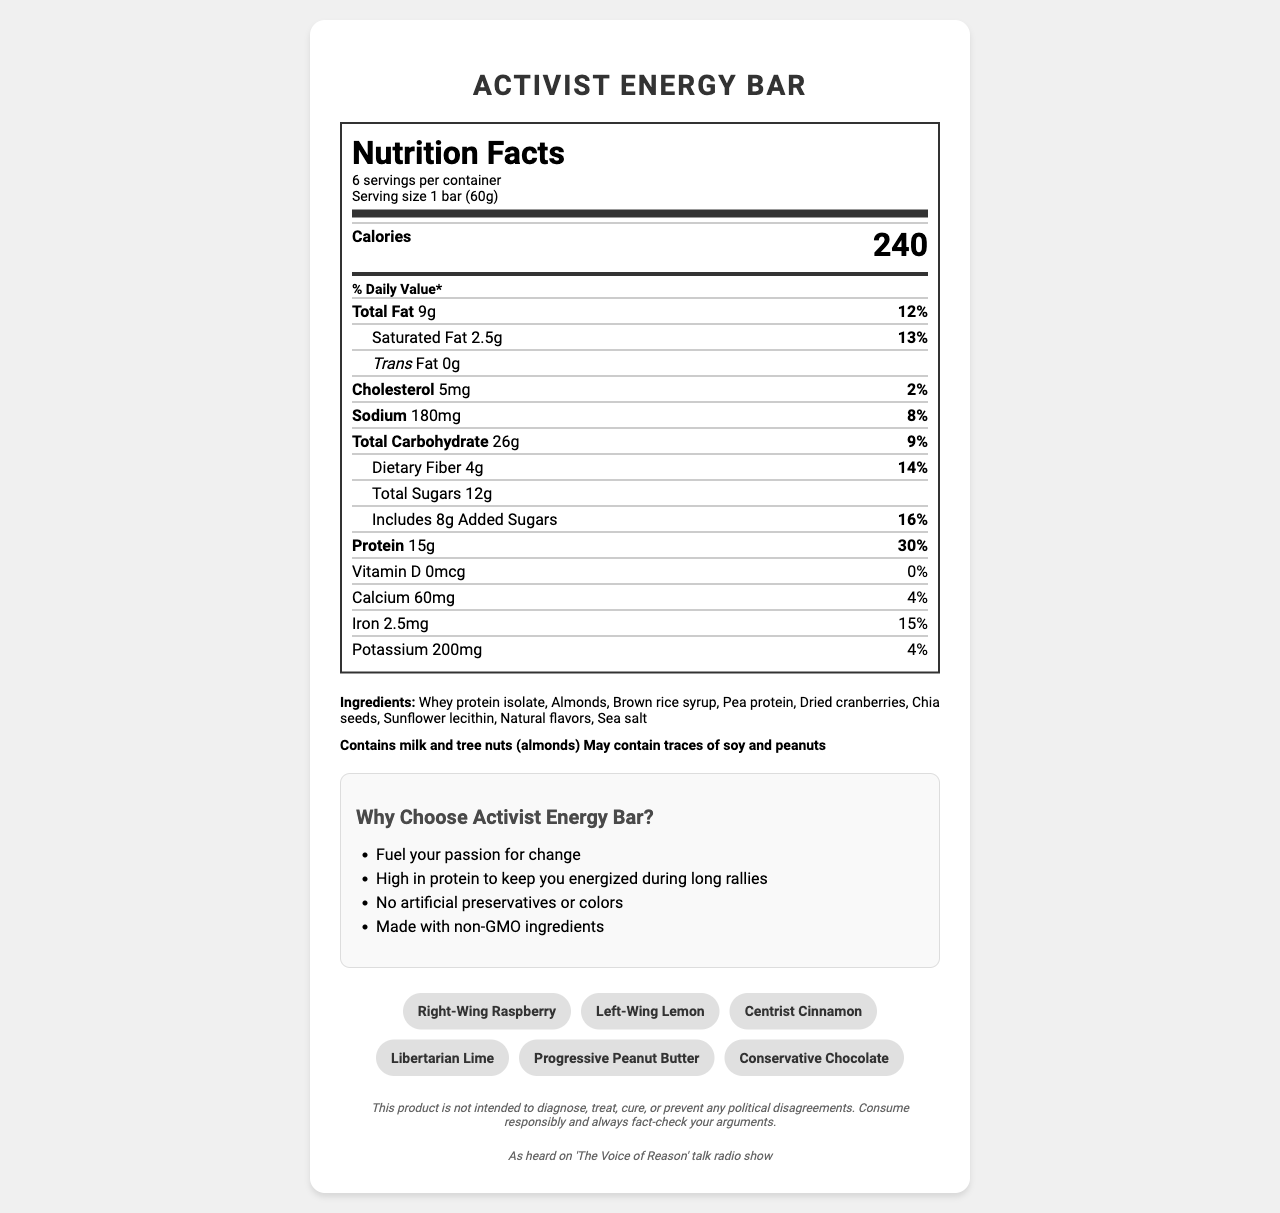what is the serving size? The serving size is listed as "1 bar (60g)" according to the document.
Answer: 1 bar (60g) how many servings are in one container? The document states that there are 6 servings per container.
Answer: 6 how many grams of protein are in one serving? The protein content per serving is stated as "15g".
Answer: 15g what percentage of the daily value of protein does one serving provide? The document indicates that one serving provides 30% of the daily value for protein.
Answer: 30% which ingredients are allergens? The allergens section lists milk and tree nuts (almonds) as allergens.
Answer: Milk and tree nuts (almonds) what is the main ingredient in the snack bar? A. Almonds B. Whey protein isolate C. Chia seeds D. Brown rice syrup The main ingredient is Whey protein isolate as it is listed first in the ingredients list.
Answer: B how many calories are there per serving? A. 240 B. 200 C. 180 D. 150 The document states there are 240 calories per serving.
Answer: A is the product marketed as non-GMO? The marketing claims include "Made with non-GMO ingredients".
Answer: Yes does the product contain artificial preservatives? One of the marketing claims is "No artificial preservatives or colors," indicating the product doesn't contain artificial preservatives.
Answer: No how much dietary fiber is in one serving? The dietary fiber content per serving is listed as "4g".
Answer: 4g what are some of the politically charged names of the flavors? These names are mentioned under the section "politically charged names".
Answer: Right-Wing Raspberry, Left-Wing Lemon, Centrist Cinnamon, Libertarian Lime, Progressive Peanut Butter, Conservative Chocolate why might this product appeal to politically active individuals? The document shows that the product has themes and marketing claims directed at politically engaged individuals.
Answer: This product is marketed with claims like "Fuel your passion for change" and has politically themed flavor names, appealing to politically active individuals. what show is the product tied to? The radio show tie-in section mentions "As heard on 'The Voice of Reason' talk radio show".
Answer: "The Voice of Reason" talk radio show what is the total carbohydrate content per serving? The document states that there are 26g of total carbohydrates per serving.
Answer: 26g does the product contain any vitamin D? The document lists vitamin D content as "0mcg", indicating no vitamin D is present.
Answer: No how does the disclaimer phrase its caution about political disagreements? The disclaimer at the bottom of the document provides this caution.
Answer: "This product is not intended to diagnose, treat, cure, or prevent any political disagreements. Consume responsibly and always fact-check your arguments." describe the main idea of the document. The document serves to inform consumers about the nutritional content and marketing angles of the Activist Energy Bar, with a special focus on its appeal to politically active individuals.
Answer: The document provides detailed nutritional information about the Activist Energy Bar, a high-protein snack bar marketed to politically active individuals. It outlines serving size, calories, and the nutritional values of various components like fats, sugar, and protein. It lists ingredients, allergens, and key marketing claims such as being non-GMO and free from artificial preservatives. Additionally, it includes politically themed flavor names and mentions a tie-in to a talk radio show. The document concludes with a disclaimer about political disagreements. how much sugar is naturally present without being added? The document only specifies "Total Sugars" and "Added Sugars" but does not provide the amount of naturally present sugars separately.
Answer: Not enough information 